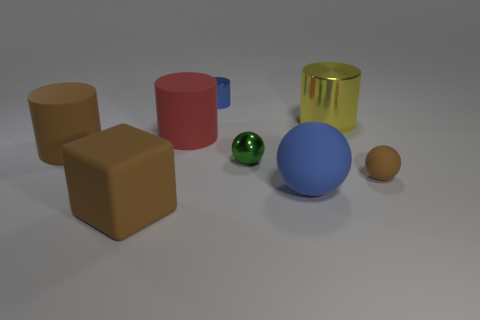What material is the green thing?
Your response must be concise. Metal. Do the blue matte thing and the yellow metal thing have the same shape?
Offer a terse response. No. Are there any tiny brown balls made of the same material as the big blue object?
Provide a succinct answer. Yes. What color is the cylinder that is both to the right of the red cylinder and to the left of the small green thing?
Keep it short and to the point. Blue. There is a large object behind the large red rubber thing; what material is it?
Your answer should be very brief. Metal. Is there a brown thing of the same shape as the big yellow metal thing?
Your response must be concise. Yes. How many other objects are the same shape as the large blue thing?
Your response must be concise. 2. There is a red rubber thing; is it the same shape as the big brown rubber thing behind the brown ball?
Your answer should be compact. Yes. There is a blue thing that is the same shape as the yellow thing; what is it made of?
Your answer should be compact. Metal. How many tiny objects are cylinders or blocks?
Give a very brief answer. 1. 